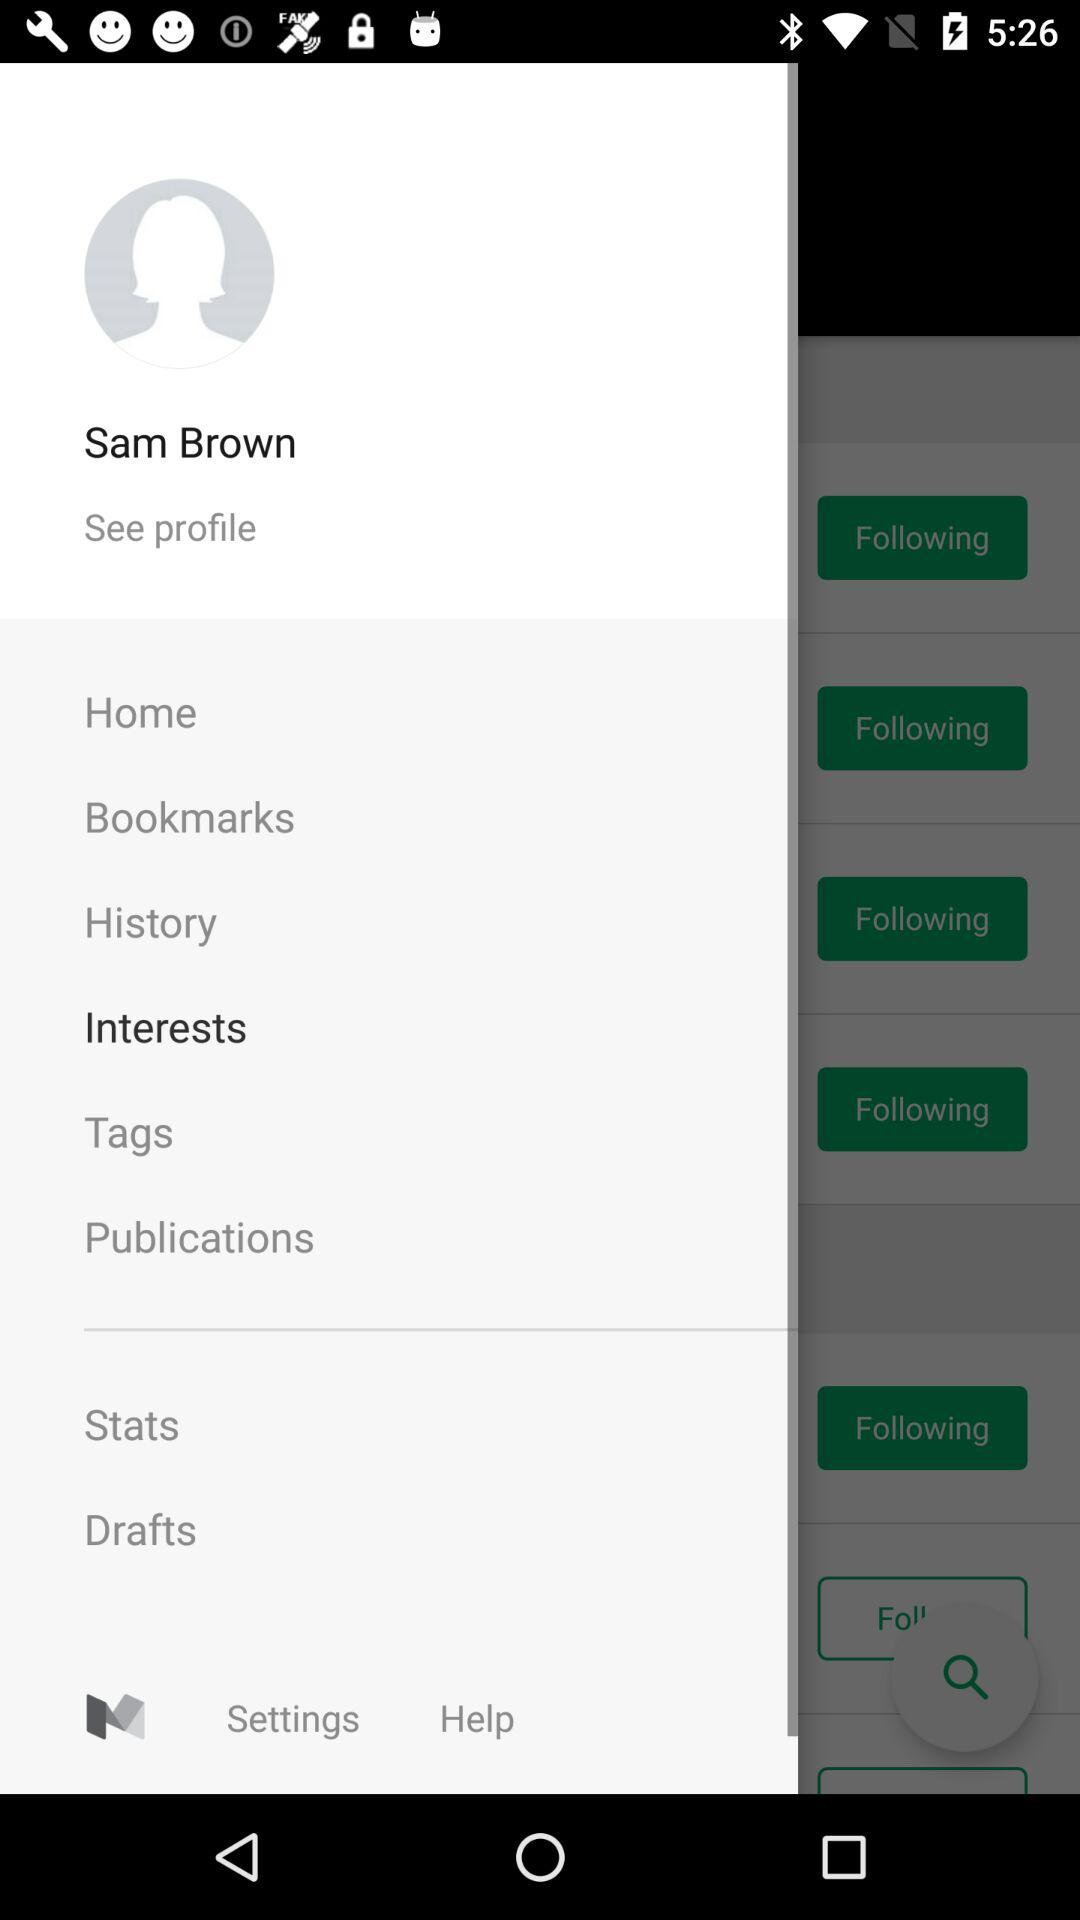What is the name of the user? The name of the user is Sam Brown. 